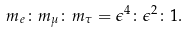Convert formula to latex. <formula><loc_0><loc_0><loc_500><loc_500>m _ { e } \colon m _ { \mu } \colon m _ { \tau } = \epsilon ^ { 4 } \colon \epsilon ^ { 2 } \colon 1 .</formula> 